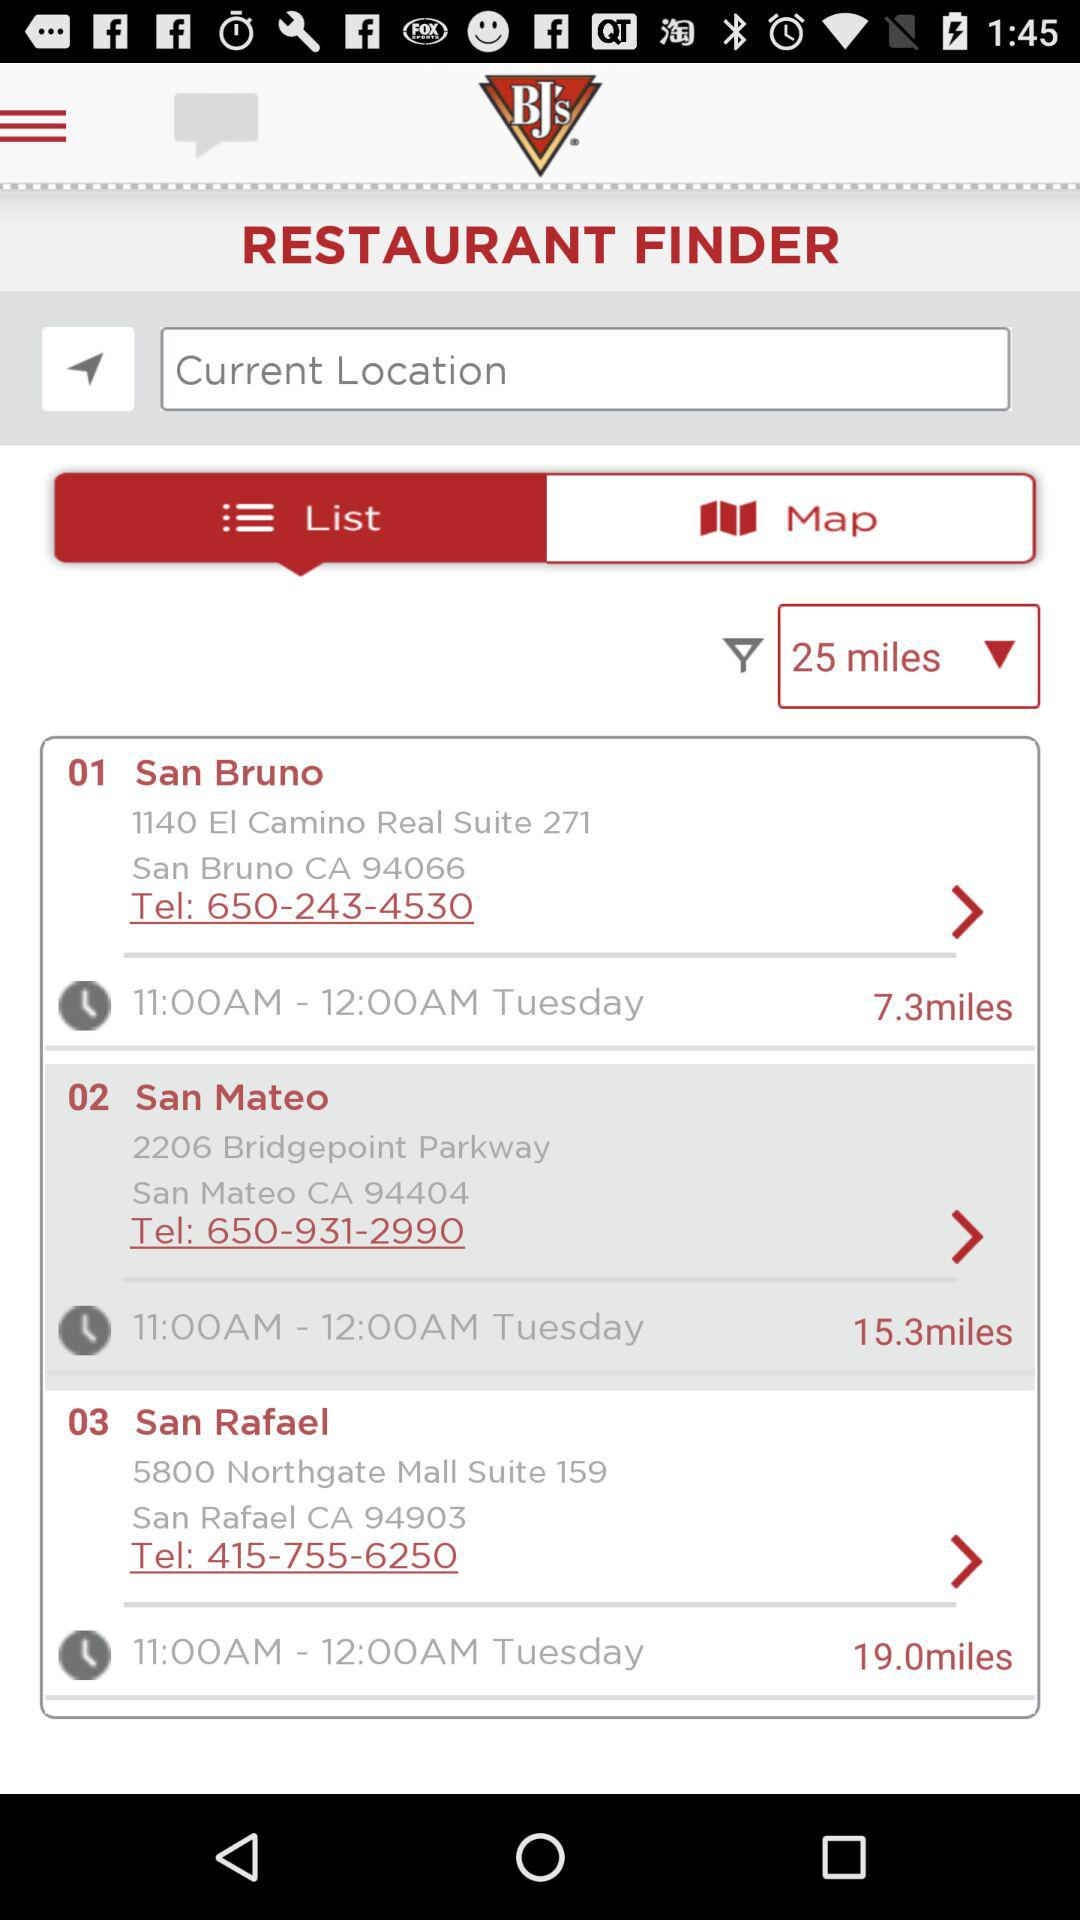What is the location of San Mateo? The location of San Mateo is 2206 Bridgepoint Parkway San Mateo CA 94404. 